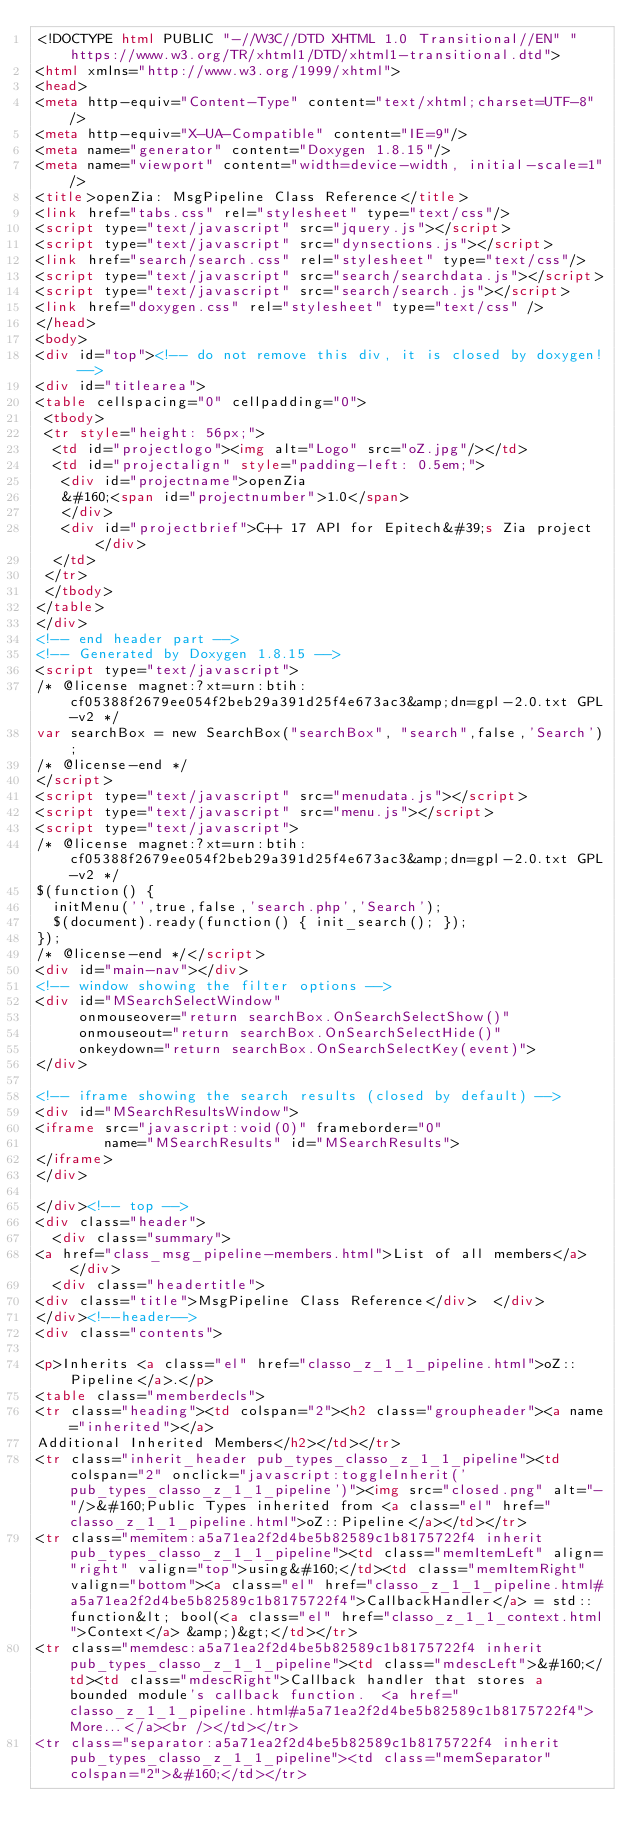Convert code to text. <code><loc_0><loc_0><loc_500><loc_500><_HTML_><!DOCTYPE html PUBLIC "-//W3C//DTD XHTML 1.0 Transitional//EN" "https://www.w3.org/TR/xhtml1/DTD/xhtml1-transitional.dtd">
<html xmlns="http://www.w3.org/1999/xhtml">
<head>
<meta http-equiv="Content-Type" content="text/xhtml;charset=UTF-8"/>
<meta http-equiv="X-UA-Compatible" content="IE=9"/>
<meta name="generator" content="Doxygen 1.8.15"/>
<meta name="viewport" content="width=device-width, initial-scale=1"/>
<title>openZia: MsgPipeline Class Reference</title>
<link href="tabs.css" rel="stylesheet" type="text/css"/>
<script type="text/javascript" src="jquery.js"></script>
<script type="text/javascript" src="dynsections.js"></script>
<link href="search/search.css" rel="stylesheet" type="text/css"/>
<script type="text/javascript" src="search/searchdata.js"></script>
<script type="text/javascript" src="search/search.js"></script>
<link href="doxygen.css" rel="stylesheet" type="text/css" />
</head>
<body>
<div id="top"><!-- do not remove this div, it is closed by doxygen! -->
<div id="titlearea">
<table cellspacing="0" cellpadding="0">
 <tbody>
 <tr style="height: 56px;">
  <td id="projectlogo"><img alt="Logo" src="oZ.jpg"/></td>
  <td id="projectalign" style="padding-left: 0.5em;">
   <div id="projectname">openZia
   &#160;<span id="projectnumber">1.0</span>
   </div>
   <div id="projectbrief">C++ 17 API for Epitech&#39;s Zia project</div>
  </td>
 </tr>
 </tbody>
</table>
</div>
<!-- end header part -->
<!-- Generated by Doxygen 1.8.15 -->
<script type="text/javascript">
/* @license magnet:?xt=urn:btih:cf05388f2679ee054f2beb29a391d25f4e673ac3&amp;dn=gpl-2.0.txt GPL-v2 */
var searchBox = new SearchBox("searchBox", "search",false,'Search');
/* @license-end */
</script>
<script type="text/javascript" src="menudata.js"></script>
<script type="text/javascript" src="menu.js"></script>
<script type="text/javascript">
/* @license magnet:?xt=urn:btih:cf05388f2679ee054f2beb29a391d25f4e673ac3&amp;dn=gpl-2.0.txt GPL-v2 */
$(function() {
  initMenu('',true,false,'search.php','Search');
  $(document).ready(function() { init_search(); });
});
/* @license-end */</script>
<div id="main-nav"></div>
<!-- window showing the filter options -->
<div id="MSearchSelectWindow"
     onmouseover="return searchBox.OnSearchSelectShow()"
     onmouseout="return searchBox.OnSearchSelectHide()"
     onkeydown="return searchBox.OnSearchSelectKey(event)">
</div>

<!-- iframe showing the search results (closed by default) -->
<div id="MSearchResultsWindow">
<iframe src="javascript:void(0)" frameborder="0" 
        name="MSearchResults" id="MSearchResults">
</iframe>
</div>

</div><!-- top -->
<div class="header">
  <div class="summary">
<a href="class_msg_pipeline-members.html">List of all members</a>  </div>
  <div class="headertitle">
<div class="title">MsgPipeline Class Reference</div>  </div>
</div><!--header-->
<div class="contents">

<p>Inherits <a class="el" href="classo_z_1_1_pipeline.html">oZ::Pipeline</a>.</p>
<table class="memberdecls">
<tr class="heading"><td colspan="2"><h2 class="groupheader"><a name="inherited"></a>
Additional Inherited Members</h2></td></tr>
<tr class="inherit_header pub_types_classo_z_1_1_pipeline"><td colspan="2" onclick="javascript:toggleInherit('pub_types_classo_z_1_1_pipeline')"><img src="closed.png" alt="-"/>&#160;Public Types inherited from <a class="el" href="classo_z_1_1_pipeline.html">oZ::Pipeline</a></td></tr>
<tr class="memitem:a5a71ea2f2d4be5b82589c1b8175722f4 inherit pub_types_classo_z_1_1_pipeline"><td class="memItemLeft" align="right" valign="top">using&#160;</td><td class="memItemRight" valign="bottom"><a class="el" href="classo_z_1_1_pipeline.html#a5a71ea2f2d4be5b82589c1b8175722f4">CallbackHandler</a> = std::function&lt; bool(<a class="el" href="classo_z_1_1_context.html">Context</a> &amp;)&gt;</td></tr>
<tr class="memdesc:a5a71ea2f2d4be5b82589c1b8175722f4 inherit pub_types_classo_z_1_1_pipeline"><td class="mdescLeft">&#160;</td><td class="mdescRight">Callback handler that stores a bounded module's callback function.  <a href="classo_z_1_1_pipeline.html#a5a71ea2f2d4be5b82589c1b8175722f4">More...</a><br /></td></tr>
<tr class="separator:a5a71ea2f2d4be5b82589c1b8175722f4 inherit pub_types_classo_z_1_1_pipeline"><td class="memSeparator" colspan="2">&#160;</td></tr></code> 